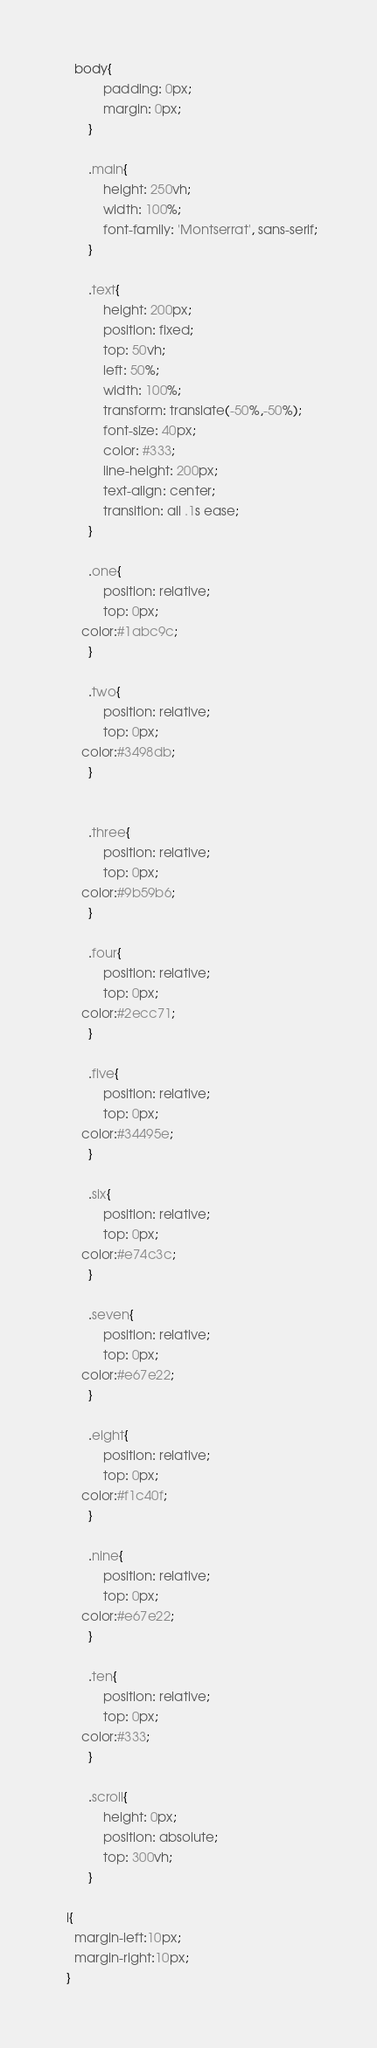<code> <loc_0><loc_0><loc_500><loc_500><_CSS_>	body{
			padding: 0px;
			margin: 0px;
		}

		.main{
			height: 250vh;
			width: 100%;
			font-family: 'Montserrat', sans-serif;
		}

		.text{
			height: 200px;
			position: fixed;
			top: 50vh;
			left: 50%;
			width: 100%;
			transform: translate(-50%,-50%);
			font-size: 40px;
			color: #333;
			line-height: 200px;
			text-align: center;
			transition: all .1s ease;
		}

		.one{
			position: relative;
			top: 0px;
      color:#1abc9c;
		}

		.two{
			position: relative;
			top: 0px;
      color:#3498db;
		}


		.three{
			position: relative;
			top: 0px;
      color:#9b59b6;
		}

		.four{
			position: relative;
			top: 0px;
      color:#2ecc71;
		}

		.five{
			position: relative;
			top: 0px;
      color:#34495e;
		}

		.six{
			position: relative;
			top: 0px;
      color:#e74c3c;
		}

		.seven{
			position: relative;
			top: 0px;
      color:#e67e22;
		}

		.eight{
			position: relative;
			top: 0px;
      color:#f1c40f;
		}

		.nine{
			position: relative;
			top: 0px;
      color:#e67e22;
		}

		.ten{
			position: relative;
			top: 0px;
      color:#333;
		}

		.scroll{
			height: 0px;
			position: absolute;
			top: 300vh;
		}
  
  i{
    margin-left:10px;
    margin-right:10px;
  }
</code> 